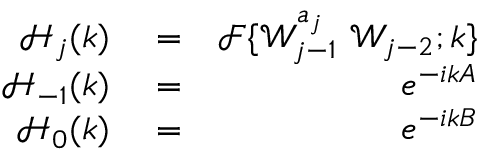<formula> <loc_0><loc_0><loc_500><loc_500>\begin{array} { r l r } { \mathcal { H } _ { j } ( k ) } & = } & { \mathcal { F } \{ \mathcal { W } _ { j - 1 } ^ { a _ { j } } \ \mathcal { W } _ { j - 2 } ; k \} } \\ { \mathcal { H } _ { - 1 } ( k ) } & = } & { e ^ { - i k A } } \\ { \mathcal { H } _ { 0 } ( k ) } & = } & { e ^ { - i k B } } \end{array}</formula> 